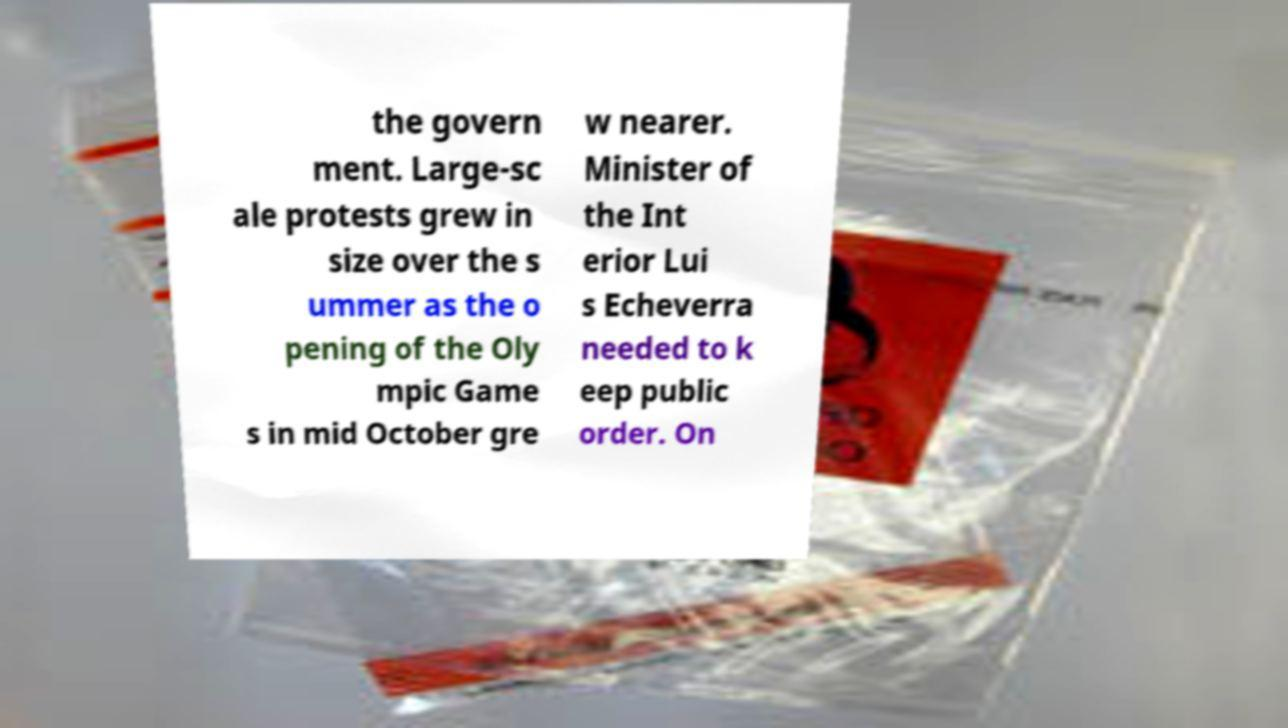Please read and relay the text visible in this image. What does it say? the govern ment. Large-sc ale protests grew in size over the s ummer as the o pening of the Oly mpic Game s in mid October gre w nearer. Minister of the Int erior Lui s Echeverra needed to k eep public order. On 